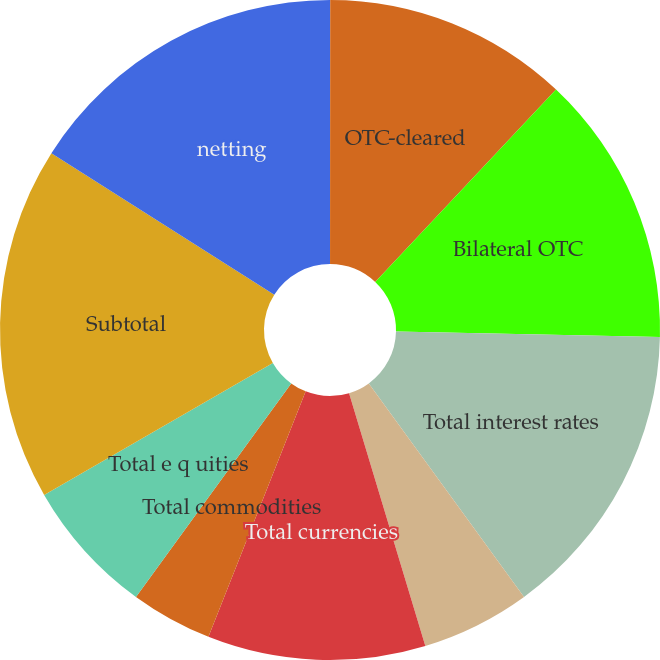<chart> <loc_0><loc_0><loc_500><loc_500><pie_chart><fcel>Exchange-traded<fcel>OTC-cleared<fcel>Bilateral OTC<fcel>Total interest rates<fcel>Total credit<fcel>Total currencies<fcel>Total commodities<fcel>Total e q uities<fcel>Subtotal<fcel>netting<nl><fcel>0.01%<fcel>12.0%<fcel>13.33%<fcel>14.66%<fcel>5.34%<fcel>10.67%<fcel>4.0%<fcel>6.67%<fcel>17.33%<fcel>16.0%<nl></chart> 